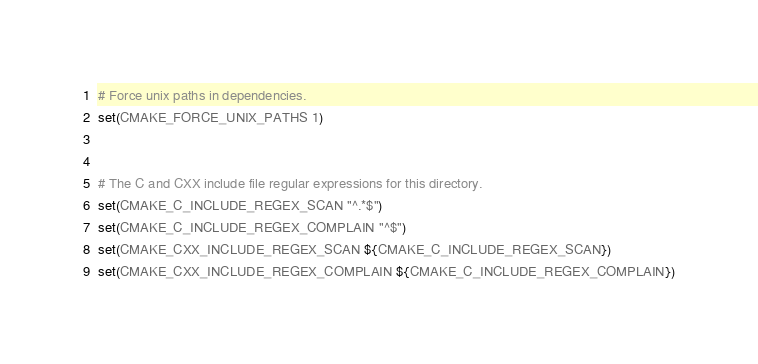<code> <loc_0><loc_0><loc_500><loc_500><_CMake_>
# Force unix paths in dependencies.
set(CMAKE_FORCE_UNIX_PATHS 1)


# The C and CXX include file regular expressions for this directory.
set(CMAKE_C_INCLUDE_REGEX_SCAN "^.*$")
set(CMAKE_C_INCLUDE_REGEX_COMPLAIN "^$")
set(CMAKE_CXX_INCLUDE_REGEX_SCAN ${CMAKE_C_INCLUDE_REGEX_SCAN})
set(CMAKE_CXX_INCLUDE_REGEX_COMPLAIN ${CMAKE_C_INCLUDE_REGEX_COMPLAIN})
</code> 